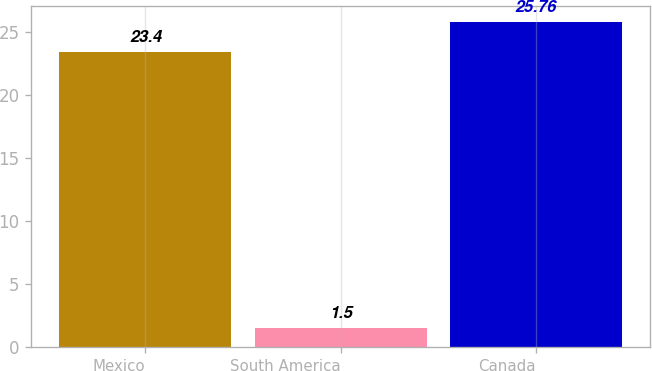<chart> <loc_0><loc_0><loc_500><loc_500><bar_chart><fcel>Mexico<fcel>South America<fcel>Canada<nl><fcel>23.4<fcel>1.5<fcel>25.76<nl></chart> 